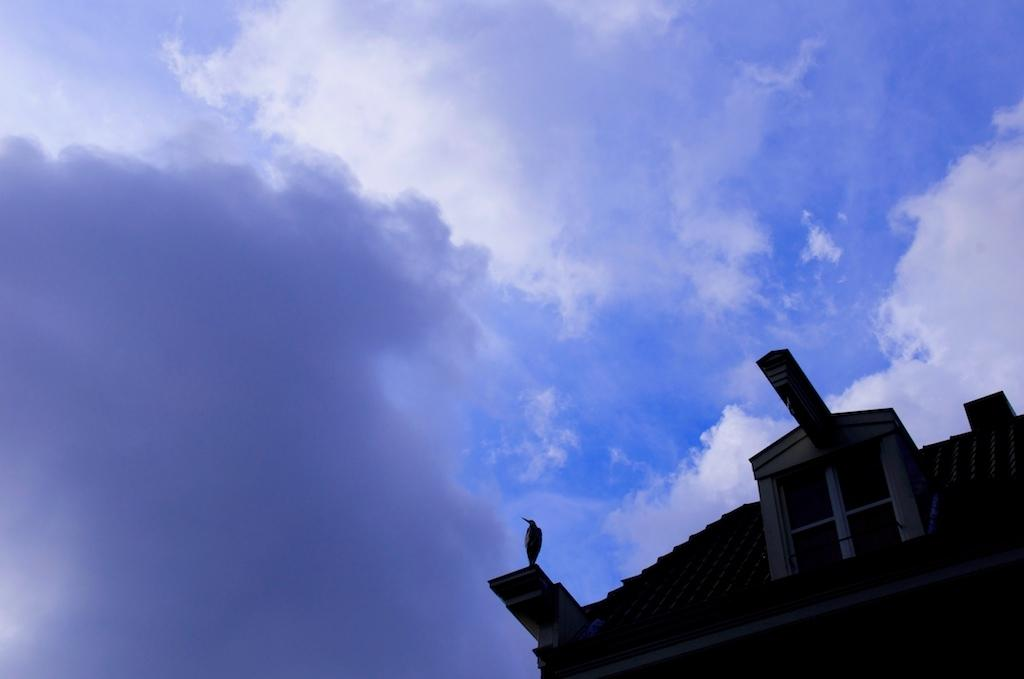What type of animal can be seen in the image? There is a bird in the image. Where is the bird located? The bird is standing on a building. What can be seen in the background of the image? The sky is visible in the background of the image. What type of ticket is the bird holding in the image? There is no ticket present in the image; it features a bird standing on a building with the sky visible in the background. 